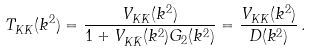Convert formula to latex. <formula><loc_0><loc_0><loc_500><loc_500>T _ { K \bar { K } } ( k ^ { 2 } ) & = \frac { V _ { K \bar { K } } ( k ^ { 2 } ) } { 1 + V _ { K \bar { K } } ( k ^ { 2 } ) G _ { 2 } ( k ^ { 2 } ) } = \frac { V _ { K \bar { K } } ( k ^ { 2 } ) } { D ( k ^ { 2 } ) } \, .</formula> 